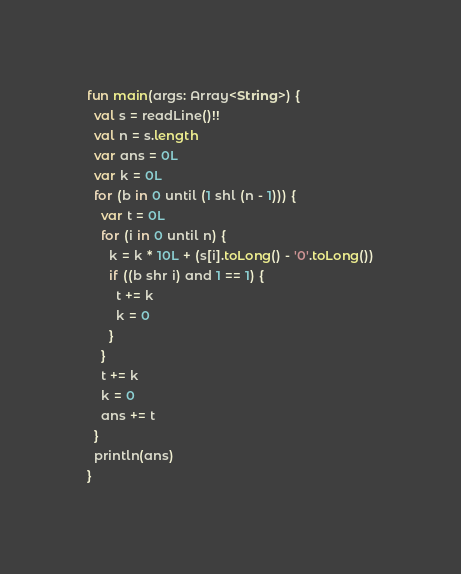<code> <loc_0><loc_0><loc_500><loc_500><_Kotlin_>fun main(args: Array<String>) {
  val s = readLine()!!
  val n = s.length
  var ans = 0L
  var k = 0L
  for (b in 0 until (1 shl (n - 1))) {
    var t = 0L
    for (i in 0 until n) {
      k = k * 10L + (s[i].toLong() - '0'.toLong())
      if ((b shr i) and 1 == 1) {
        t += k
        k = 0
      }
    }
    t += k
    k = 0
    ans += t
  }
  println(ans)
}
</code> 